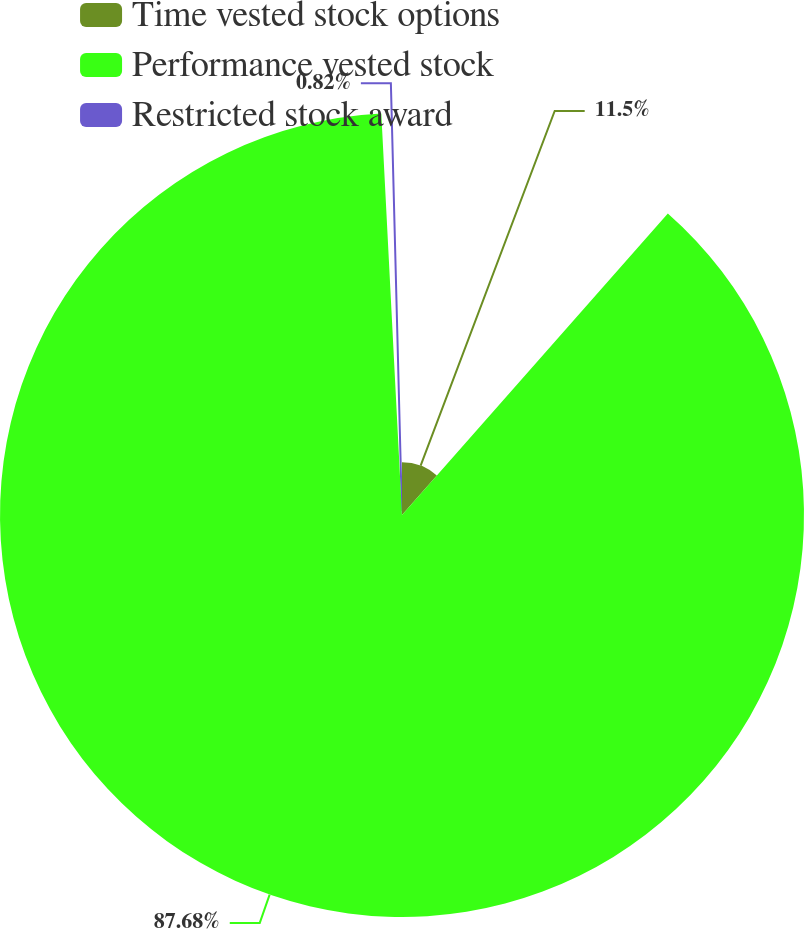Convert chart to OTSL. <chart><loc_0><loc_0><loc_500><loc_500><pie_chart><fcel>Time vested stock options<fcel>Performance vested stock<fcel>Restricted stock award<nl><fcel>11.5%<fcel>87.68%<fcel>0.82%<nl></chart> 